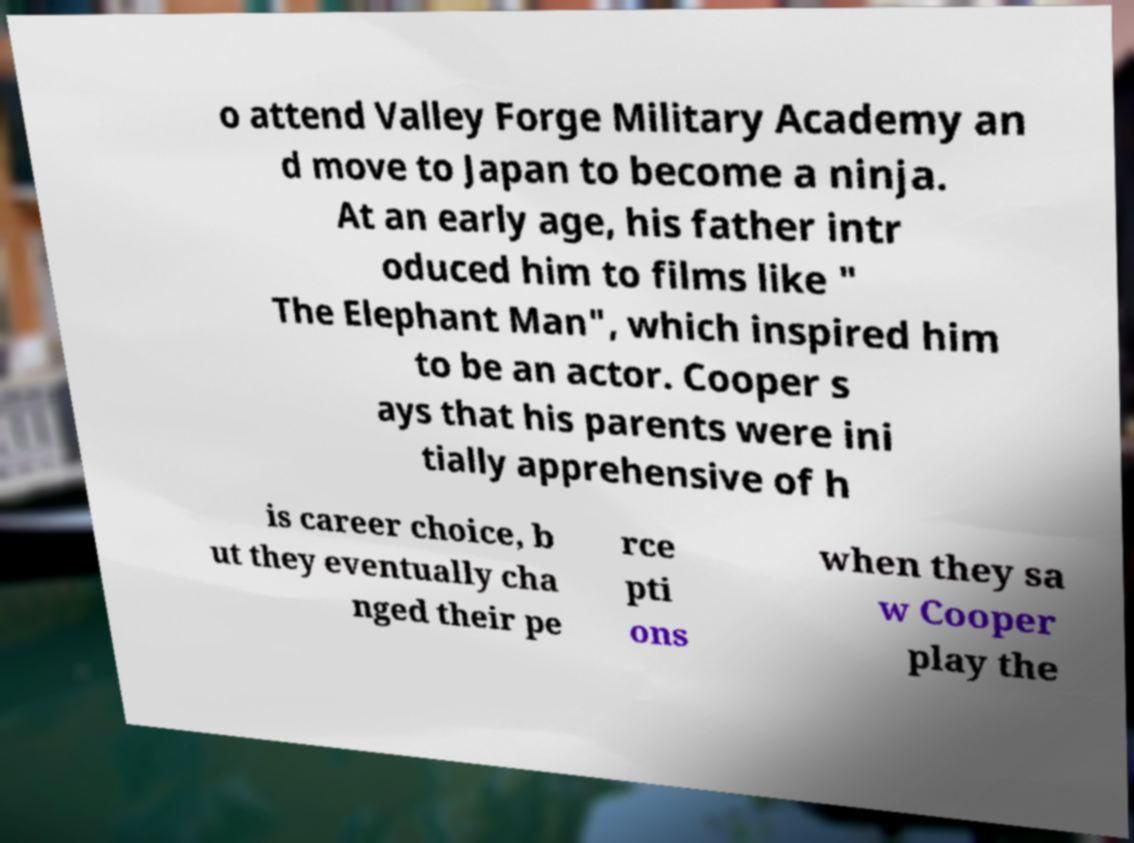Can you read and provide the text displayed in the image?This photo seems to have some interesting text. Can you extract and type it out for me? o attend Valley Forge Military Academy an d move to Japan to become a ninja. At an early age, his father intr oduced him to films like " The Elephant Man", which inspired him to be an actor. Cooper s ays that his parents were ini tially apprehensive of h is career choice, b ut they eventually cha nged their pe rce pti ons when they sa w Cooper play the 